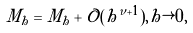Convert formula to latex. <formula><loc_0><loc_0><loc_500><loc_500>\tilde { M } _ { h } = M _ { h } + \mathcal { O } ( h ^ { \nu + 1 } ) , h \rightarrow 0 ,</formula> 